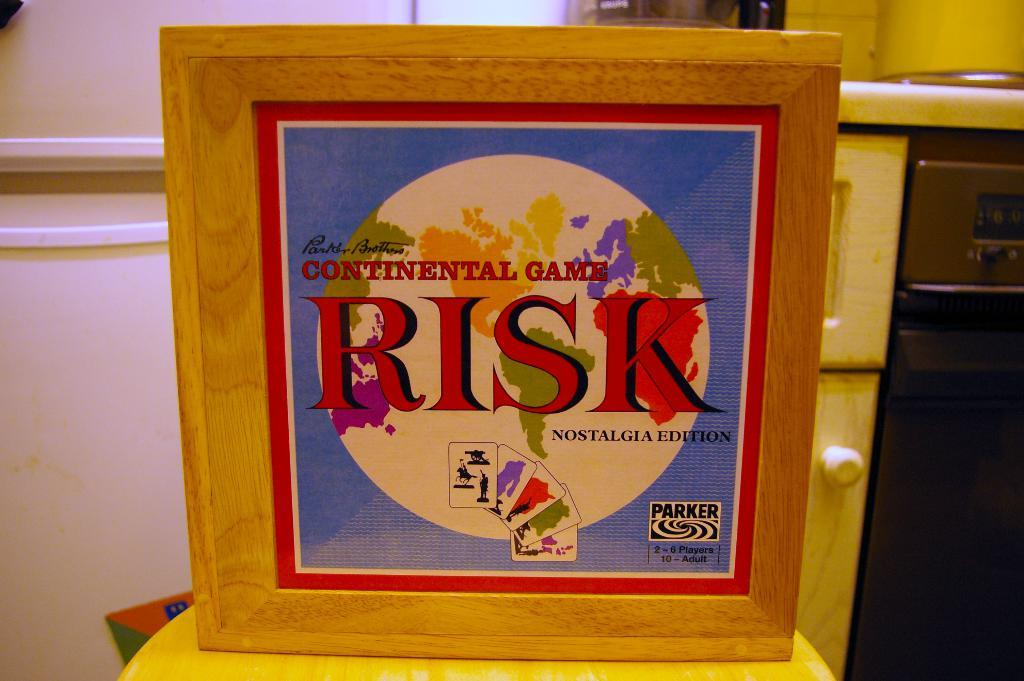<image>
Share a concise interpretation of the image provided. The Nostalgia Edition of the board game, Risk. 